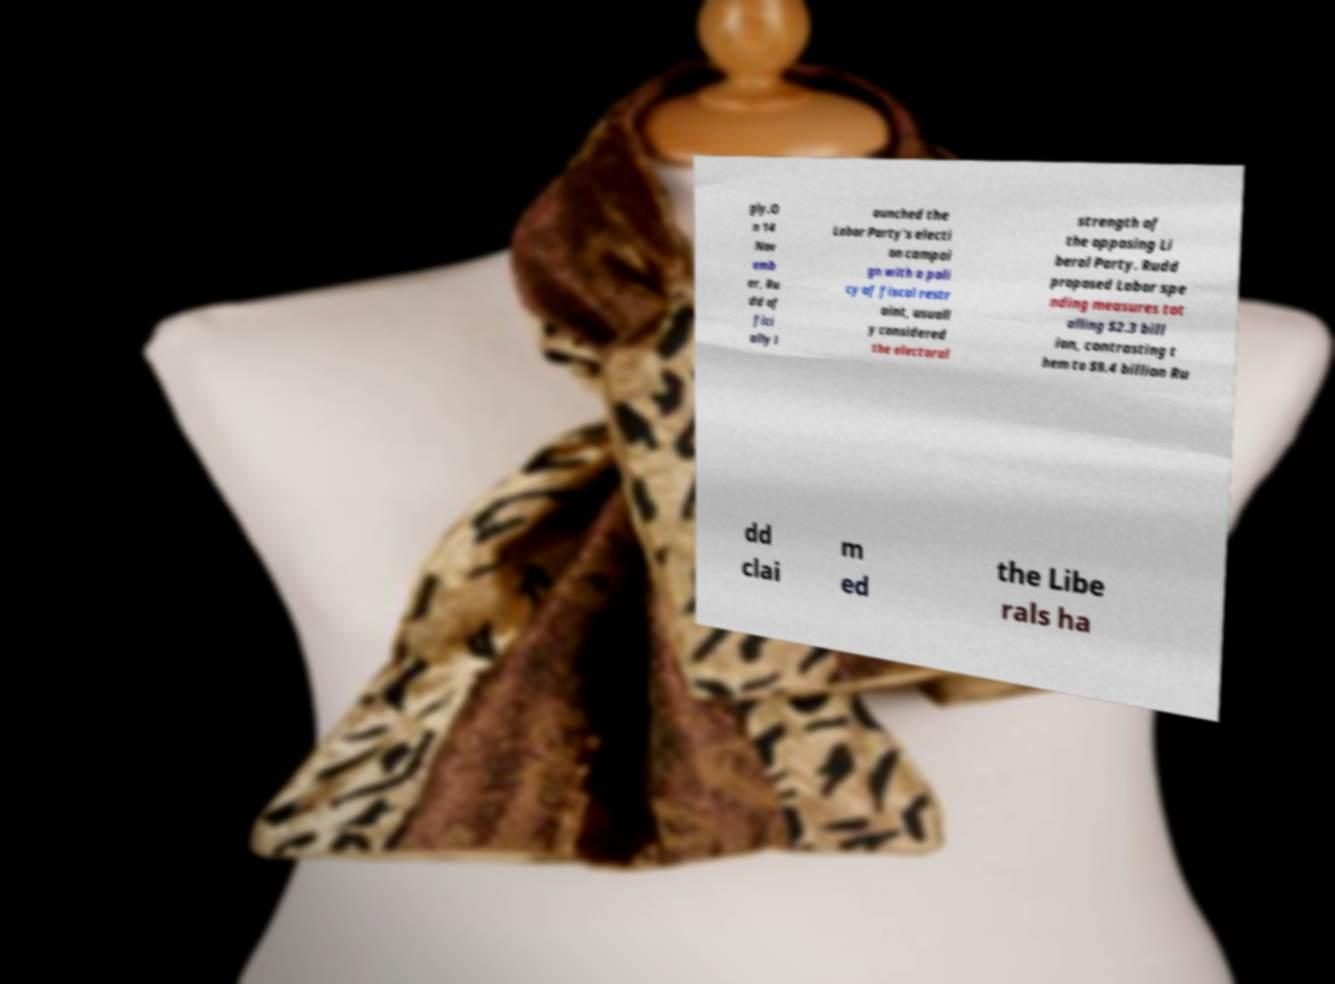There's text embedded in this image that I need extracted. Can you transcribe it verbatim? gly.O n 14 Nov emb er, Ru dd of fici ally l aunched the Labor Party's electi on campai gn with a poli cy of fiscal restr aint, usuall y considered the electoral strength of the opposing Li beral Party. Rudd proposed Labor spe nding measures tot alling $2.3 bill ion, contrasting t hem to $9.4 billion Ru dd clai m ed the Libe rals ha 